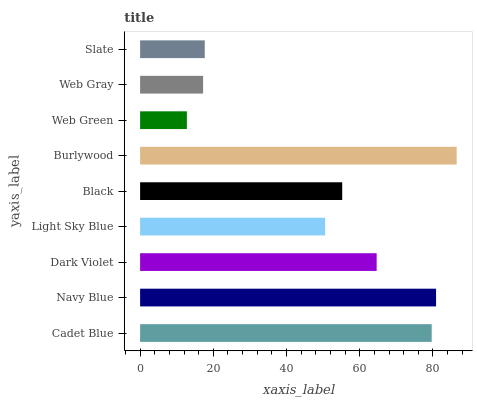Is Web Green the minimum?
Answer yes or no. Yes. Is Burlywood the maximum?
Answer yes or no. Yes. Is Navy Blue the minimum?
Answer yes or no. No. Is Navy Blue the maximum?
Answer yes or no. No. Is Navy Blue greater than Cadet Blue?
Answer yes or no. Yes. Is Cadet Blue less than Navy Blue?
Answer yes or no. Yes. Is Cadet Blue greater than Navy Blue?
Answer yes or no. No. Is Navy Blue less than Cadet Blue?
Answer yes or no. No. Is Black the high median?
Answer yes or no. Yes. Is Black the low median?
Answer yes or no. Yes. Is Navy Blue the high median?
Answer yes or no. No. Is Web Green the low median?
Answer yes or no. No. 